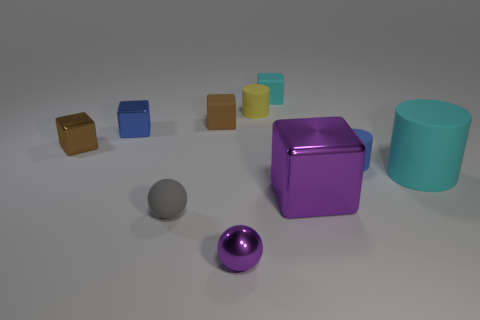Subtract all small blocks. How many blocks are left? 1 Subtract all blue blocks. How many blocks are left? 4 Subtract all spheres. How many objects are left? 8 Subtract all purple cylinders. How many brown cubes are left? 2 Add 3 cylinders. How many cylinders exist? 6 Subtract 0 green cylinders. How many objects are left? 10 Subtract 1 balls. How many balls are left? 1 Subtract all yellow balls. Subtract all blue cylinders. How many balls are left? 2 Subtract all tiny green rubber spheres. Subtract all matte blocks. How many objects are left? 8 Add 4 tiny purple things. How many tiny purple things are left? 5 